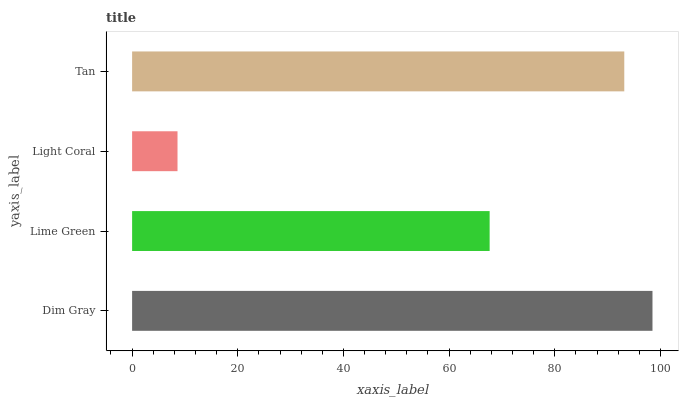Is Light Coral the minimum?
Answer yes or no. Yes. Is Dim Gray the maximum?
Answer yes or no. Yes. Is Lime Green the minimum?
Answer yes or no. No. Is Lime Green the maximum?
Answer yes or no. No. Is Dim Gray greater than Lime Green?
Answer yes or no. Yes. Is Lime Green less than Dim Gray?
Answer yes or no. Yes. Is Lime Green greater than Dim Gray?
Answer yes or no. No. Is Dim Gray less than Lime Green?
Answer yes or no. No. Is Tan the high median?
Answer yes or no. Yes. Is Lime Green the low median?
Answer yes or no. Yes. Is Light Coral the high median?
Answer yes or no. No. Is Dim Gray the low median?
Answer yes or no. No. 